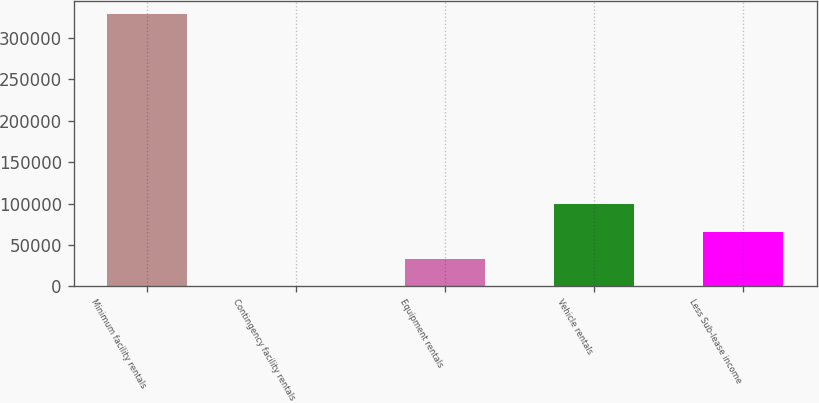Convert chart. <chart><loc_0><loc_0><loc_500><loc_500><bar_chart><fcel>Minimum facility rentals<fcel>Contingency facility rentals<fcel>Equipment rentals<fcel>Vehicle rentals<fcel>Less Sub-lease income<nl><fcel>328581<fcel>578<fcel>33378.3<fcel>98978.9<fcel>66178.6<nl></chart> 